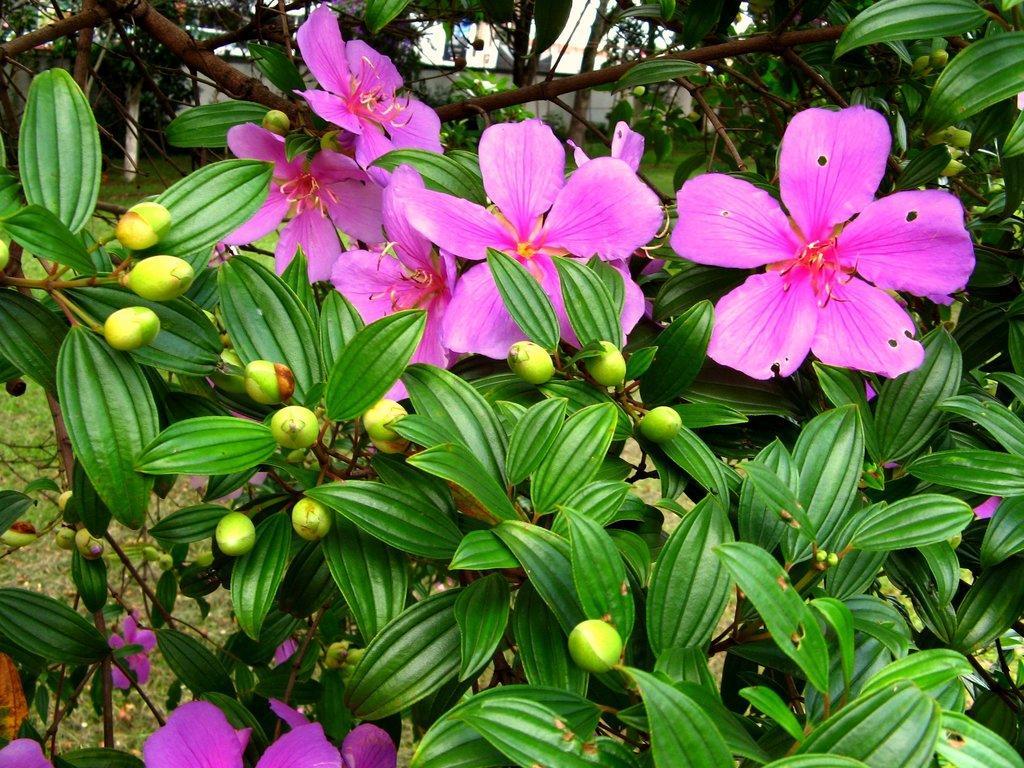How would you summarize this image in a sentence or two? In this picture we can see pink flowers,buds and green leaves. 